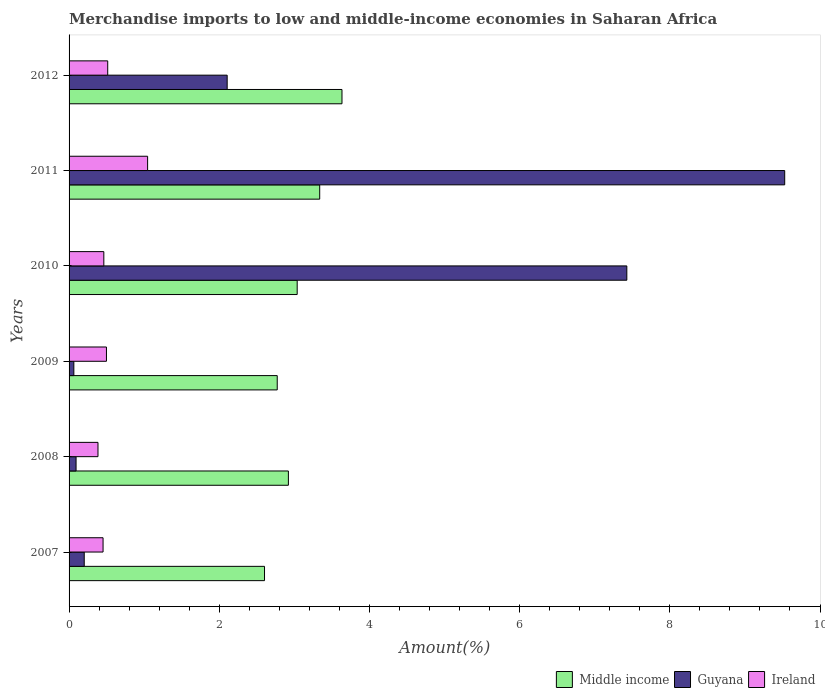How many groups of bars are there?
Your answer should be compact. 6. Are the number of bars on each tick of the Y-axis equal?
Provide a short and direct response. Yes. What is the label of the 3rd group of bars from the top?
Your answer should be very brief. 2010. What is the percentage of amount earned from merchandise imports in Guyana in 2008?
Ensure brevity in your answer.  0.09. Across all years, what is the maximum percentage of amount earned from merchandise imports in Middle income?
Offer a terse response. 3.63. Across all years, what is the minimum percentage of amount earned from merchandise imports in Middle income?
Your response must be concise. 2.6. In which year was the percentage of amount earned from merchandise imports in Guyana minimum?
Offer a terse response. 2009. What is the total percentage of amount earned from merchandise imports in Middle income in the graph?
Provide a succinct answer. 18.31. What is the difference between the percentage of amount earned from merchandise imports in Guyana in 2010 and that in 2011?
Provide a succinct answer. -2.1. What is the difference between the percentage of amount earned from merchandise imports in Guyana in 2010 and the percentage of amount earned from merchandise imports in Ireland in 2009?
Provide a short and direct response. 6.93. What is the average percentage of amount earned from merchandise imports in Middle income per year?
Ensure brevity in your answer.  3.05. In the year 2007, what is the difference between the percentage of amount earned from merchandise imports in Guyana and percentage of amount earned from merchandise imports in Middle income?
Your answer should be very brief. -2.4. In how many years, is the percentage of amount earned from merchandise imports in Middle income greater than 2 %?
Your answer should be very brief. 6. What is the ratio of the percentage of amount earned from merchandise imports in Middle income in 2010 to that in 2012?
Provide a short and direct response. 0.84. Is the percentage of amount earned from merchandise imports in Guyana in 2007 less than that in 2011?
Keep it short and to the point. Yes. What is the difference between the highest and the second highest percentage of amount earned from merchandise imports in Ireland?
Give a very brief answer. 0.53. What is the difference between the highest and the lowest percentage of amount earned from merchandise imports in Ireland?
Offer a terse response. 0.66. In how many years, is the percentage of amount earned from merchandise imports in Middle income greater than the average percentage of amount earned from merchandise imports in Middle income taken over all years?
Keep it short and to the point. 2. Is the sum of the percentage of amount earned from merchandise imports in Guyana in 2008 and 2010 greater than the maximum percentage of amount earned from merchandise imports in Ireland across all years?
Offer a very short reply. Yes. What does the 2nd bar from the bottom in 2012 represents?
Keep it short and to the point. Guyana. How many bars are there?
Your response must be concise. 18. How many years are there in the graph?
Your answer should be very brief. 6. What is the difference between two consecutive major ticks on the X-axis?
Keep it short and to the point. 2. Are the values on the major ticks of X-axis written in scientific E-notation?
Ensure brevity in your answer.  No. Does the graph contain any zero values?
Offer a very short reply. No. Does the graph contain grids?
Your response must be concise. No. Where does the legend appear in the graph?
Keep it short and to the point. Bottom right. How are the legend labels stacked?
Offer a terse response. Horizontal. What is the title of the graph?
Keep it short and to the point. Merchandise imports to low and middle-income economies in Saharan Africa. Does "Bhutan" appear as one of the legend labels in the graph?
Your answer should be compact. No. What is the label or title of the X-axis?
Give a very brief answer. Amount(%). What is the label or title of the Y-axis?
Offer a terse response. Years. What is the Amount(%) of Middle income in 2007?
Provide a succinct answer. 2.6. What is the Amount(%) in Guyana in 2007?
Your answer should be compact. 0.2. What is the Amount(%) in Ireland in 2007?
Your answer should be very brief. 0.45. What is the Amount(%) of Middle income in 2008?
Your answer should be very brief. 2.92. What is the Amount(%) in Guyana in 2008?
Offer a terse response. 0.09. What is the Amount(%) of Ireland in 2008?
Your answer should be compact. 0.38. What is the Amount(%) in Middle income in 2009?
Offer a very short reply. 2.77. What is the Amount(%) in Guyana in 2009?
Provide a succinct answer. 0.06. What is the Amount(%) in Ireland in 2009?
Ensure brevity in your answer.  0.5. What is the Amount(%) of Middle income in 2010?
Offer a very short reply. 3.04. What is the Amount(%) of Guyana in 2010?
Offer a very short reply. 7.43. What is the Amount(%) of Ireland in 2010?
Offer a very short reply. 0.46. What is the Amount(%) of Middle income in 2011?
Keep it short and to the point. 3.34. What is the Amount(%) in Guyana in 2011?
Make the answer very short. 9.53. What is the Amount(%) in Ireland in 2011?
Give a very brief answer. 1.05. What is the Amount(%) in Middle income in 2012?
Ensure brevity in your answer.  3.63. What is the Amount(%) in Guyana in 2012?
Provide a short and direct response. 2.11. What is the Amount(%) in Ireland in 2012?
Offer a very short reply. 0.51. Across all years, what is the maximum Amount(%) of Middle income?
Give a very brief answer. 3.63. Across all years, what is the maximum Amount(%) of Guyana?
Give a very brief answer. 9.53. Across all years, what is the maximum Amount(%) of Ireland?
Offer a very short reply. 1.05. Across all years, what is the minimum Amount(%) in Middle income?
Ensure brevity in your answer.  2.6. Across all years, what is the minimum Amount(%) of Guyana?
Make the answer very short. 0.06. Across all years, what is the minimum Amount(%) of Ireland?
Provide a succinct answer. 0.38. What is the total Amount(%) of Middle income in the graph?
Your response must be concise. 18.31. What is the total Amount(%) of Guyana in the graph?
Provide a succinct answer. 19.42. What is the total Amount(%) in Ireland in the graph?
Your answer should be very brief. 3.36. What is the difference between the Amount(%) in Middle income in 2007 and that in 2008?
Keep it short and to the point. -0.32. What is the difference between the Amount(%) in Guyana in 2007 and that in 2008?
Make the answer very short. 0.11. What is the difference between the Amount(%) in Ireland in 2007 and that in 2008?
Ensure brevity in your answer.  0.07. What is the difference between the Amount(%) of Middle income in 2007 and that in 2009?
Make the answer very short. -0.17. What is the difference between the Amount(%) of Guyana in 2007 and that in 2009?
Your answer should be very brief. 0.14. What is the difference between the Amount(%) in Ireland in 2007 and that in 2009?
Your response must be concise. -0.05. What is the difference between the Amount(%) in Middle income in 2007 and that in 2010?
Ensure brevity in your answer.  -0.43. What is the difference between the Amount(%) in Guyana in 2007 and that in 2010?
Ensure brevity in your answer.  -7.23. What is the difference between the Amount(%) in Ireland in 2007 and that in 2010?
Offer a very short reply. -0.01. What is the difference between the Amount(%) of Middle income in 2007 and that in 2011?
Keep it short and to the point. -0.73. What is the difference between the Amount(%) in Guyana in 2007 and that in 2011?
Offer a terse response. -9.33. What is the difference between the Amount(%) in Ireland in 2007 and that in 2011?
Your answer should be compact. -0.59. What is the difference between the Amount(%) of Middle income in 2007 and that in 2012?
Make the answer very short. -1.03. What is the difference between the Amount(%) of Guyana in 2007 and that in 2012?
Keep it short and to the point. -1.9. What is the difference between the Amount(%) of Ireland in 2007 and that in 2012?
Offer a terse response. -0.06. What is the difference between the Amount(%) of Middle income in 2008 and that in 2009?
Make the answer very short. 0.15. What is the difference between the Amount(%) in Guyana in 2008 and that in 2009?
Make the answer very short. 0.03. What is the difference between the Amount(%) in Ireland in 2008 and that in 2009?
Give a very brief answer. -0.11. What is the difference between the Amount(%) of Middle income in 2008 and that in 2010?
Provide a short and direct response. -0.12. What is the difference between the Amount(%) of Guyana in 2008 and that in 2010?
Give a very brief answer. -7.33. What is the difference between the Amount(%) in Ireland in 2008 and that in 2010?
Provide a short and direct response. -0.08. What is the difference between the Amount(%) of Middle income in 2008 and that in 2011?
Make the answer very short. -0.42. What is the difference between the Amount(%) of Guyana in 2008 and that in 2011?
Give a very brief answer. -9.44. What is the difference between the Amount(%) of Ireland in 2008 and that in 2011?
Make the answer very short. -0.66. What is the difference between the Amount(%) in Middle income in 2008 and that in 2012?
Give a very brief answer. -0.71. What is the difference between the Amount(%) in Guyana in 2008 and that in 2012?
Offer a terse response. -2.01. What is the difference between the Amount(%) in Ireland in 2008 and that in 2012?
Offer a terse response. -0.13. What is the difference between the Amount(%) of Middle income in 2009 and that in 2010?
Offer a terse response. -0.27. What is the difference between the Amount(%) in Guyana in 2009 and that in 2010?
Your answer should be very brief. -7.36. What is the difference between the Amount(%) in Ireland in 2009 and that in 2010?
Offer a very short reply. 0.04. What is the difference between the Amount(%) in Middle income in 2009 and that in 2011?
Your answer should be compact. -0.57. What is the difference between the Amount(%) in Guyana in 2009 and that in 2011?
Offer a terse response. -9.47. What is the difference between the Amount(%) of Ireland in 2009 and that in 2011?
Make the answer very short. -0.55. What is the difference between the Amount(%) in Middle income in 2009 and that in 2012?
Your response must be concise. -0.86. What is the difference between the Amount(%) of Guyana in 2009 and that in 2012?
Offer a very short reply. -2.04. What is the difference between the Amount(%) of Ireland in 2009 and that in 2012?
Make the answer very short. -0.02. What is the difference between the Amount(%) in Middle income in 2010 and that in 2011?
Make the answer very short. -0.3. What is the difference between the Amount(%) in Guyana in 2010 and that in 2011?
Ensure brevity in your answer.  -2.1. What is the difference between the Amount(%) in Ireland in 2010 and that in 2011?
Offer a very short reply. -0.58. What is the difference between the Amount(%) of Middle income in 2010 and that in 2012?
Give a very brief answer. -0.6. What is the difference between the Amount(%) of Guyana in 2010 and that in 2012?
Offer a terse response. 5.32. What is the difference between the Amount(%) of Ireland in 2010 and that in 2012?
Make the answer very short. -0.05. What is the difference between the Amount(%) of Middle income in 2011 and that in 2012?
Your answer should be very brief. -0.3. What is the difference between the Amount(%) in Guyana in 2011 and that in 2012?
Provide a succinct answer. 7.42. What is the difference between the Amount(%) of Ireland in 2011 and that in 2012?
Your answer should be compact. 0.53. What is the difference between the Amount(%) in Middle income in 2007 and the Amount(%) in Guyana in 2008?
Your answer should be very brief. 2.51. What is the difference between the Amount(%) in Middle income in 2007 and the Amount(%) in Ireland in 2008?
Keep it short and to the point. 2.22. What is the difference between the Amount(%) of Guyana in 2007 and the Amount(%) of Ireland in 2008?
Your response must be concise. -0.18. What is the difference between the Amount(%) of Middle income in 2007 and the Amount(%) of Guyana in 2009?
Make the answer very short. 2.54. What is the difference between the Amount(%) in Middle income in 2007 and the Amount(%) in Ireland in 2009?
Provide a succinct answer. 2.1. What is the difference between the Amount(%) of Guyana in 2007 and the Amount(%) of Ireland in 2009?
Ensure brevity in your answer.  -0.3. What is the difference between the Amount(%) of Middle income in 2007 and the Amount(%) of Guyana in 2010?
Offer a very short reply. -4.82. What is the difference between the Amount(%) of Middle income in 2007 and the Amount(%) of Ireland in 2010?
Keep it short and to the point. 2.14. What is the difference between the Amount(%) of Guyana in 2007 and the Amount(%) of Ireland in 2010?
Offer a terse response. -0.26. What is the difference between the Amount(%) in Middle income in 2007 and the Amount(%) in Guyana in 2011?
Ensure brevity in your answer.  -6.93. What is the difference between the Amount(%) in Middle income in 2007 and the Amount(%) in Ireland in 2011?
Keep it short and to the point. 1.56. What is the difference between the Amount(%) of Guyana in 2007 and the Amount(%) of Ireland in 2011?
Your answer should be compact. -0.84. What is the difference between the Amount(%) of Middle income in 2007 and the Amount(%) of Guyana in 2012?
Offer a terse response. 0.5. What is the difference between the Amount(%) of Middle income in 2007 and the Amount(%) of Ireland in 2012?
Give a very brief answer. 2.09. What is the difference between the Amount(%) in Guyana in 2007 and the Amount(%) in Ireland in 2012?
Provide a succinct answer. -0.31. What is the difference between the Amount(%) in Middle income in 2008 and the Amount(%) in Guyana in 2009?
Provide a short and direct response. 2.86. What is the difference between the Amount(%) of Middle income in 2008 and the Amount(%) of Ireland in 2009?
Offer a very short reply. 2.42. What is the difference between the Amount(%) in Guyana in 2008 and the Amount(%) in Ireland in 2009?
Offer a very short reply. -0.4. What is the difference between the Amount(%) in Middle income in 2008 and the Amount(%) in Guyana in 2010?
Provide a succinct answer. -4.51. What is the difference between the Amount(%) of Middle income in 2008 and the Amount(%) of Ireland in 2010?
Make the answer very short. 2.46. What is the difference between the Amount(%) in Guyana in 2008 and the Amount(%) in Ireland in 2010?
Ensure brevity in your answer.  -0.37. What is the difference between the Amount(%) of Middle income in 2008 and the Amount(%) of Guyana in 2011?
Make the answer very short. -6.61. What is the difference between the Amount(%) of Middle income in 2008 and the Amount(%) of Ireland in 2011?
Ensure brevity in your answer.  1.87. What is the difference between the Amount(%) of Guyana in 2008 and the Amount(%) of Ireland in 2011?
Offer a very short reply. -0.95. What is the difference between the Amount(%) of Middle income in 2008 and the Amount(%) of Guyana in 2012?
Ensure brevity in your answer.  0.82. What is the difference between the Amount(%) in Middle income in 2008 and the Amount(%) in Ireland in 2012?
Offer a very short reply. 2.41. What is the difference between the Amount(%) in Guyana in 2008 and the Amount(%) in Ireland in 2012?
Keep it short and to the point. -0.42. What is the difference between the Amount(%) of Middle income in 2009 and the Amount(%) of Guyana in 2010?
Keep it short and to the point. -4.66. What is the difference between the Amount(%) of Middle income in 2009 and the Amount(%) of Ireland in 2010?
Your answer should be compact. 2.31. What is the difference between the Amount(%) in Guyana in 2009 and the Amount(%) in Ireland in 2010?
Your answer should be compact. -0.4. What is the difference between the Amount(%) of Middle income in 2009 and the Amount(%) of Guyana in 2011?
Ensure brevity in your answer.  -6.76. What is the difference between the Amount(%) in Middle income in 2009 and the Amount(%) in Ireland in 2011?
Your answer should be compact. 1.73. What is the difference between the Amount(%) in Guyana in 2009 and the Amount(%) in Ireland in 2011?
Your answer should be compact. -0.98. What is the difference between the Amount(%) of Middle income in 2009 and the Amount(%) of Guyana in 2012?
Offer a very short reply. 0.67. What is the difference between the Amount(%) in Middle income in 2009 and the Amount(%) in Ireland in 2012?
Your answer should be very brief. 2.26. What is the difference between the Amount(%) of Guyana in 2009 and the Amount(%) of Ireland in 2012?
Ensure brevity in your answer.  -0.45. What is the difference between the Amount(%) in Middle income in 2010 and the Amount(%) in Guyana in 2011?
Ensure brevity in your answer.  -6.49. What is the difference between the Amount(%) of Middle income in 2010 and the Amount(%) of Ireland in 2011?
Provide a short and direct response. 1.99. What is the difference between the Amount(%) in Guyana in 2010 and the Amount(%) in Ireland in 2011?
Keep it short and to the point. 6.38. What is the difference between the Amount(%) of Middle income in 2010 and the Amount(%) of Guyana in 2012?
Make the answer very short. 0.93. What is the difference between the Amount(%) in Middle income in 2010 and the Amount(%) in Ireland in 2012?
Your response must be concise. 2.52. What is the difference between the Amount(%) of Guyana in 2010 and the Amount(%) of Ireland in 2012?
Your response must be concise. 6.91. What is the difference between the Amount(%) in Middle income in 2011 and the Amount(%) in Guyana in 2012?
Provide a succinct answer. 1.23. What is the difference between the Amount(%) of Middle income in 2011 and the Amount(%) of Ireland in 2012?
Offer a terse response. 2.82. What is the difference between the Amount(%) of Guyana in 2011 and the Amount(%) of Ireland in 2012?
Your answer should be very brief. 9.02. What is the average Amount(%) in Middle income per year?
Keep it short and to the point. 3.05. What is the average Amount(%) in Guyana per year?
Offer a very short reply. 3.24. What is the average Amount(%) in Ireland per year?
Your answer should be compact. 0.56. In the year 2007, what is the difference between the Amount(%) of Middle income and Amount(%) of Guyana?
Offer a very short reply. 2.4. In the year 2007, what is the difference between the Amount(%) in Middle income and Amount(%) in Ireland?
Provide a succinct answer. 2.15. In the year 2007, what is the difference between the Amount(%) in Guyana and Amount(%) in Ireland?
Give a very brief answer. -0.25. In the year 2008, what is the difference between the Amount(%) of Middle income and Amount(%) of Guyana?
Keep it short and to the point. 2.83. In the year 2008, what is the difference between the Amount(%) of Middle income and Amount(%) of Ireland?
Ensure brevity in your answer.  2.54. In the year 2008, what is the difference between the Amount(%) in Guyana and Amount(%) in Ireland?
Offer a very short reply. -0.29. In the year 2009, what is the difference between the Amount(%) in Middle income and Amount(%) in Guyana?
Provide a short and direct response. 2.71. In the year 2009, what is the difference between the Amount(%) in Middle income and Amount(%) in Ireland?
Provide a succinct answer. 2.27. In the year 2009, what is the difference between the Amount(%) of Guyana and Amount(%) of Ireland?
Your response must be concise. -0.43. In the year 2010, what is the difference between the Amount(%) of Middle income and Amount(%) of Guyana?
Keep it short and to the point. -4.39. In the year 2010, what is the difference between the Amount(%) in Middle income and Amount(%) in Ireland?
Your answer should be compact. 2.58. In the year 2010, what is the difference between the Amount(%) in Guyana and Amount(%) in Ireland?
Provide a succinct answer. 6.96. In the year 2011, what is the difference between the Amount(%) of Middle income and Amount(%) of Guyana?
Give a very brief answer. -6.19. In the year 2011, what is the difference between the Amount(%) in Middle income and Amount(%) in Ireland?
Provide a short and direct response. 2.29. In the year 2011, what is the difference between the Amount(%) in Guyana and Amount(%) in Ireland?
Keep it short and to the point. 8.48. In the year 2012, what is the difference between the Amount(%) of Middle income and Amount(%) of Guyana?
Your answer should be very brief. 1.53. In the year 2012, what is the difference between the Amount(%) of Middle income and Amount(%) of Ireland?
Your answer should be very brief. 3.12. In the year 2012, what is the difference between the Amount(%) of Guyana and Amount(%) of Ireland?
Your answer should be very brief. 1.59. What is the ratio of the Amount(%) of Middle income in 2007 to that in 2008?
Ensure brevity in your answer.  0.89. What is the ratio of the Amount(%) in Guyana in 2007 to that in 2008?
Provide a short and direct response. 2.17. What is the ratio of the Amount(%) in Ireland in 2007 to that in 2008?
Your answer should be very brief. 1.18. What is the ratio of the Amount(%) of Middle income in 2007 to that in 2009?
Your answer should be very brief. 0.94. What is the ratio of the Amount(%) of Guyana in 2007 to that in 2009?
Provide a short and direct response. 3.17. What is the ratio of the Amount(%) in Middle income in 2007 to that in 2010?
Your answer should be very brief. 0.86. What is the ratio of the Amount(%) of Guyana in 2007 to that in 2010?
Your response must be concise. 0.03. What is the ratio of the Amount(%) in Ireland in 2007 to that in 2010?
Ensure brevity in your answer.  0.98. What is the ratio of the Amount(%) of Middle income in 2007 to that in 2011?
Give a very brief answer. 0.78. What is the ratio of the Amount(%) in Guyana in 2007 to that in 2011?
Your answer should be very brief. 0.02. What is the ratio of the Amount(%) in Ireland in 2007 to that in 2011?
Keep it short and to the point. 0.43. What is the ratio of the Amount(%) of Middle income in 2007 to that in 2012?
Offer a terse response. 0.72. What is the ratio of the Amount(%) of Guyana in 2007 to that in 2012?
Give a very brief answer. 0.1. What is the ratio of the Amount(%) of Ireland in 2007 to that in 2012?
Ensure brevity in your answer.  0.88. What is the ratio of the Amount(%) in Middle income in 2008 to that in 2009?
Your answer should be very brief. 1.05. What is the ratio of the Amount(%) in Guyana in 2008 to that in 2009?
Offer a very short reply. 1.47. What is the ratio of the Amount(%) in Ireland in 2008 to that in 2009?
Provide a succinct answer. 0.77. What is the ratio of the Amount(%) of Middle income in 2008 to that in 2010?
Provide a short and direct response. 0.96. What is the ratio of the Amount(%) in Guyana in 2008 to that in 2010?
Your answer should be very brief. 0.01. What is the ratio of the Amount(%) of Ireland in 2008 to that in 2010?
Ensure brevity in your answer.  0.83. What is the ratio of the Amount(%) in Guyana in 2008 to that in 2011?
Offer a terse response. 0.01. What is the ratio of the Amount(%) of Ireland in 2008 to that in 2011?
Your answer should be very brief. 0.37. What is the ratio of the Amount(%) in Middle income in 2008 to that in 2012?
Your answer should be very brief. 0.8. What is the ratio of the Amount(%) of Guyana in 2008 to that in 2012?
Provide a short and direct response. 0.04. What is the ratio of the Amount(%) in Ireland in 2008 to that in 2012?
Provide a succinct answer. 0.75. What is the ratio of the Amount(%) in Middle income in 2009 to that in 2010?
Make the answer very short. 0.91. What is the ratio of the Amount(%) of Guyana in 2009 to that in 2010?
Offer a terse response. 0.01. What is the ratio of the Amount(%) of Ireland in 2009 to that in 2010?
Provide a short and direct response. 1.08. What is the ratio of the Amount(%) in Middle income in 2009 to that in 2011?
Provide a short and direct response. 0.83. What is the ratio of the Amount(%) of Guyana in 2009 to that in 2011?
Offer a very short reply. 0.01. What is the ratio of the Amount(%) of Ireland in 2009 to that in 2011?
Offer a terse response. 0.48. What is the ratio of the Amount(%) in Middle income in 2009 to that in 2012?
Provide a succinct answer. 0.76. What is the ratio of the Amount(%) of Guyana in 2009 to that in 2012?
Ensure brevity in your answer.  0.03. What is the ratio of the Amount(%) in Ireland in 2009 to that in 2012?
Make the answer very short. 0.97. What is the ratio of the Amount(%) of Middle income in 2010 to that in 2011?
Provide a short and direct response. 0.91. What is the ratio of the Amount(%) in Guyana in 2010 to that in 2011?
Offer a terse response. 0.78. What is the ratio of the Amount(%) of Ireland in 2010 to that in 2011?
Keep it short and to the point. 0.44. What is the ratio of the Amount(%) of Middle income in 2010 to that in 2012?
Offer a terse response. 0.84. What is the ratio of the Amount(%) of Guyana in 2010 to that in 2012?
Your answer should be compact. 3.53. What is the ratio of the Amount(%) in Ireland in 2010 to that in 2012?
Offer a very short reply. 0.9. What is the ratio of the Amount(%) of Middle income in 2011 to that in 2012?
Your answer should be compact. 0.92. What is the ratio of the Amount(%) in Guyana in 2011 to that in 2012?
Make the answer very short. 4.53. What is the ratio of the Amount(%) of Ireland in 2011 to that in 2012?
Your answer should be very brief. 2.03. What is the difference between the highest and the second highest Amount(%) of Middle income?
Ensure brevity in your answer.  0.3. What is the difference between the highest and the second highest Amount(%) in Guyana?
Your answer should be very brief. 2.1. What is the difference between the highest and the second highest Amount(%) in Ireland?
Your response must be concise. 0.53. What is the difference between the highest and the lowest Amount(%) in Middle income?
Make the answer very short. 1.03. What is the difference between the highest and the lowest Amount(%) in Guyana?
Give a very brief answer. 9.47. What is the difference between the highest and the lowest Amount(%) of Ireland?
Offer a terse response. 0.66. 